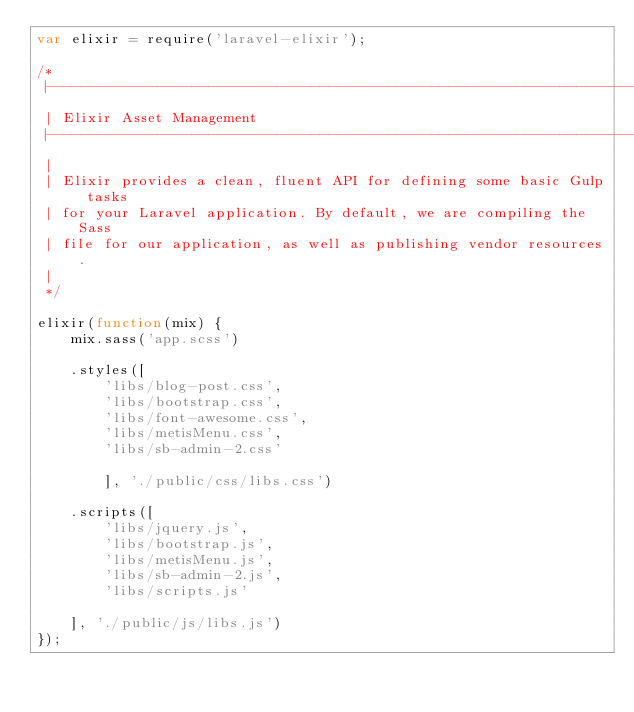<code> <loc_0><loc_0><loc_500><loc_500><_JavaScript_>var elixir = require('laravel-elixir');

/*
 |--------------------------------------------------------------------------
 | Elixir Asset Management
 |--------------------------------------------------------------------------
 |
 | Elixir provides a clean, fluent API for defining some basic Gulp tasks
 | for your Laravel application. By default, we are compiling the Sass
 | file for our application, as well as publishing vendor resources.
 |
 */

elixir(function(mix) {
    mix.sass('app.scss')

    .styles([
        'libs/blog-post.css',
        'libs/bootstrap.css',
        'libs/font-awesome.css',
        'libs/metisMenu.css',
        'libs/sb-admin-2.css'

        ], './public/css/libs.css')

    .scripts([
        'libs/jquery.js',
        'libs/bootstrap.js',
        'libs/metisMenu.js',
        'libs/sb-admin-2.js',
        'libs/scripts.js'

    ], './public/js/libs.js')
});
</code> 